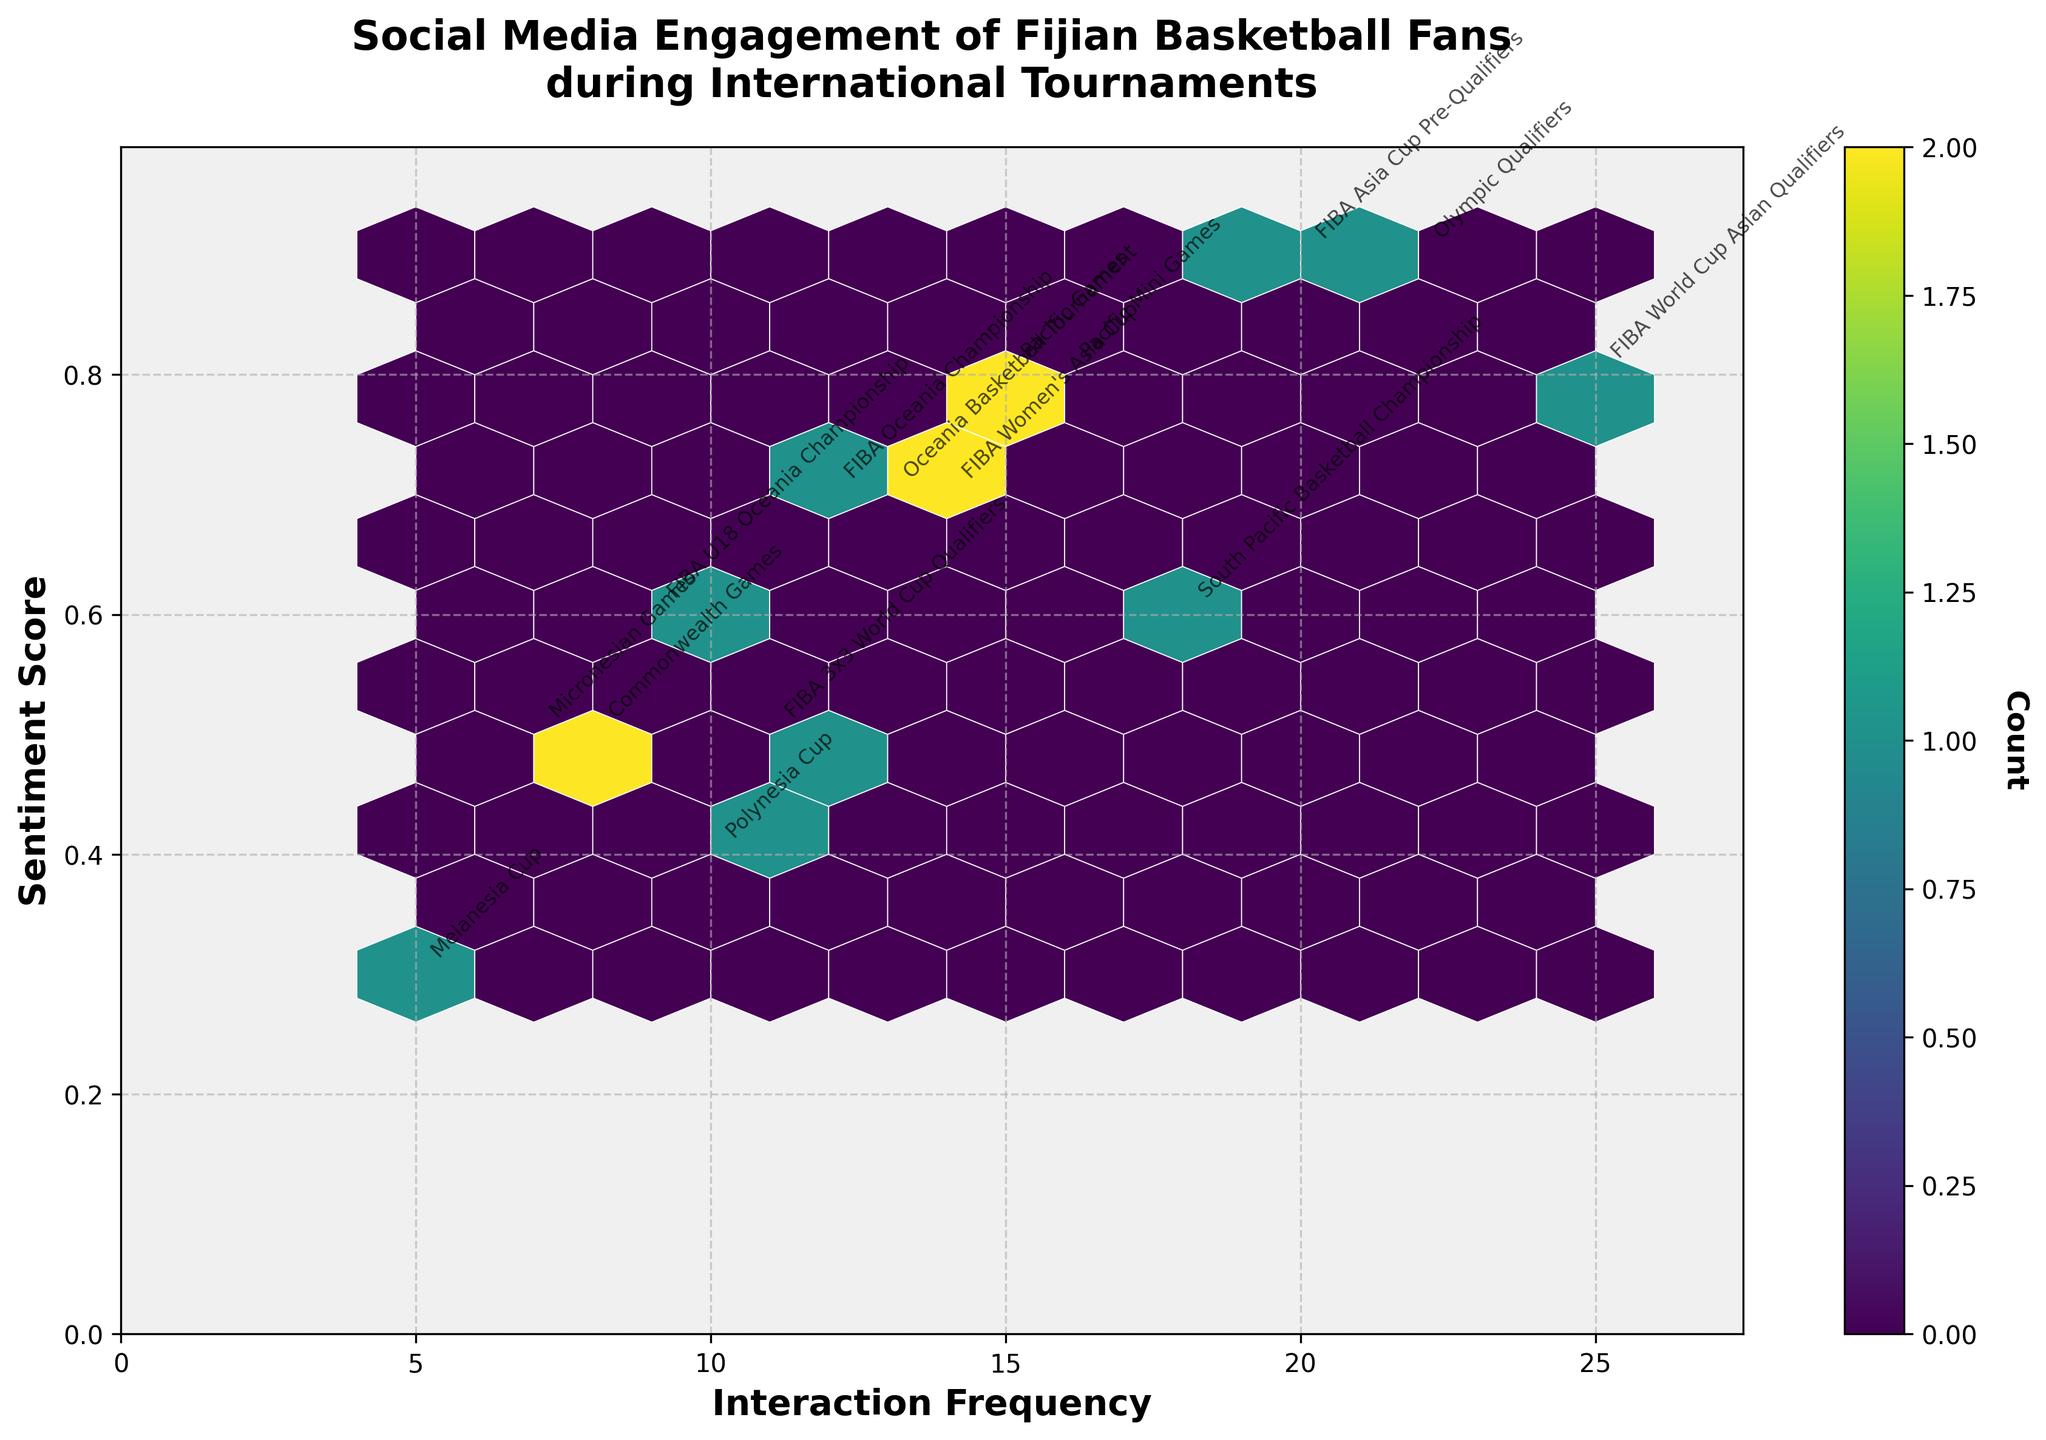What is the title of the figure? The title is usually located at the top of the figure. The title for this plot is written in bold and large font.
Answer: Social Media Engagement of Fijian Basketball Fans during International Tournaments What are the labels of the x and y axis? The labels are usually placed next to the respective axes. In this figure, the x-axis label is 'Interaction Frequency' and the y-axis label is 'Sentiment Score'.
Answer: Interaction Frequency, Sentiment Score How many hexagons are there in the plot? By counting the hexagons present in the plot, you can identify the number of hexagons. As every tournament's data point is located within a distinct hexbin, there are 10 hexagons in the plot.
Answer: 10 Which tournament has the highest interaction frequency? The tournament with the highest interaction frequency will have its data point positioned furthest to the right along the x-axis. From the annotations, we observe that the 'FIBA World Cup Asian Qualifiers' data point is the furthest to the right.
Answer: FIBA World Cup Asian Qualifiers What is the average sentiment score of the tournaments? To find the average sentiment score, sum all the sentiment scores and divide by the number of tournaments. Sum: 0.7 + 0.8 + 0.5 + 0.9 + 0.3 + 0.6 + 0.4 + 0.8 + 0.5 + 0.7 + 0.9 + 0.6 + 0.8 + 0.5 + 0.7 = 10.7. Average = 10.7 / 15 = 0.71.
Answer: 0.71 Which tournaments have a sentiment score of 0.5 or less? Tournaments with a sentiment score of 0.5 or less will fall along or below the y = 0.5 mark on the y-axis. Here, the tournaments are 'Commonwealth Games', 'Melanesia Cup', 'Polynesia Cup', 'Micronesian Games', and 'FIBA 3x3 World Cup Qualifiers'.
Answer: Commonwealth Games, Melanesia Cup, Polynesia Cup, Micronesian Games, FIBA 3x3 World Cup Qualifiers Which tournament has the highest sentiment score combined with high interaction frequency? By examining the top right corner of the plot where both interaction frequency and sentiment score are high, we see that 'Olympic Qualifiers' have the highest sentiment score and a high interaction frequency.
Answer: Olympic Qualifiers What is the interaction frequency range on the x-axis? The range can be found by taking the difference between the maximum and minimum values on the x-axis. From the data, the highest interaction frequency is 25 (FIBA World Cup Asian Qualifiers) and the lowest is 5 (Melanesia Cup). The range is 25 - 5 = 20.
Answer: 20 For the given tournaments, is there a positive correlation between interaction frequency and sentiment score? In a hexbin plot, a positive correlation is indicated when data points generally trend upwards as they move to the right. Visual inspection of the plot shows that higher interaction frequencies are associated with higher sentiment scores, implying a positive correlation.
Answer: Yes 